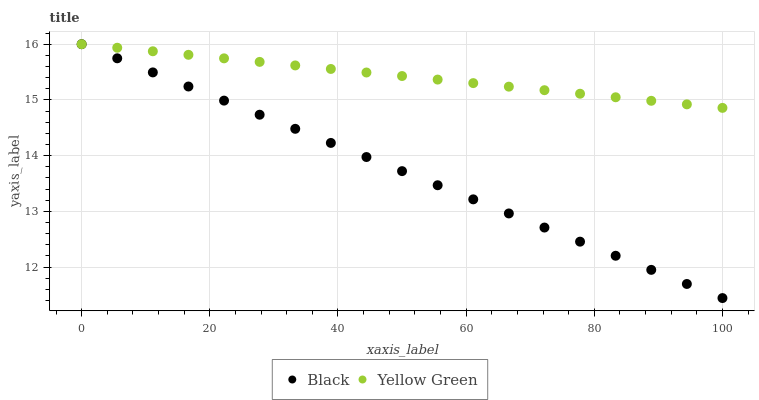Does Black have the minimum area under the curve?
Answer yes or no. Yes. Does Yellow Green have the maximum area under the curve?
Answer yes or no. Yes. Does Yellow Green have the minimum area under the curve?
Answer yes or no. No. Is Yellow Green the smoothest?
Answer yes or no. Yes. Is Black the roughest?
Answer yes or no. Yes. Is Yellow Green the roughest?
Answer yes or no. No. Does Black have the lowest value?
Answer yes or no. Yes. Does Yellow Green have the lowest value?
Answer yes or no. No. Does Yellow Green have the highest value?
Answer yes or no. Yes. Does Black intersect Yellow Green?
Answer yes or no. Yes. Is Black less than Yellow Green?
Answer yes or no. No. Is Black greater than Yellow Green?
Answer yes or no. No. 